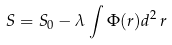<formula> <loc_0><loc_0><loc_500><loc_500>S = S _ { 0 } - \lambda \int \Phi ( r ) d ^ { 2 } \, r</formula> 